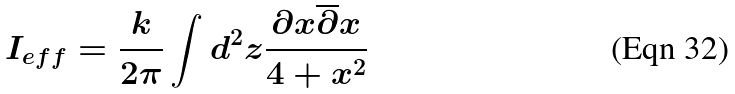<formula> <loc_0><loc_0><loc_500><loc_500>I _ { e f f } = \frac { k } { 2 \pi } \int d ^ { 2 } z \frac { \partial x \overline { \partial } x } { 4 + x ^ { 2 } }</formula> 